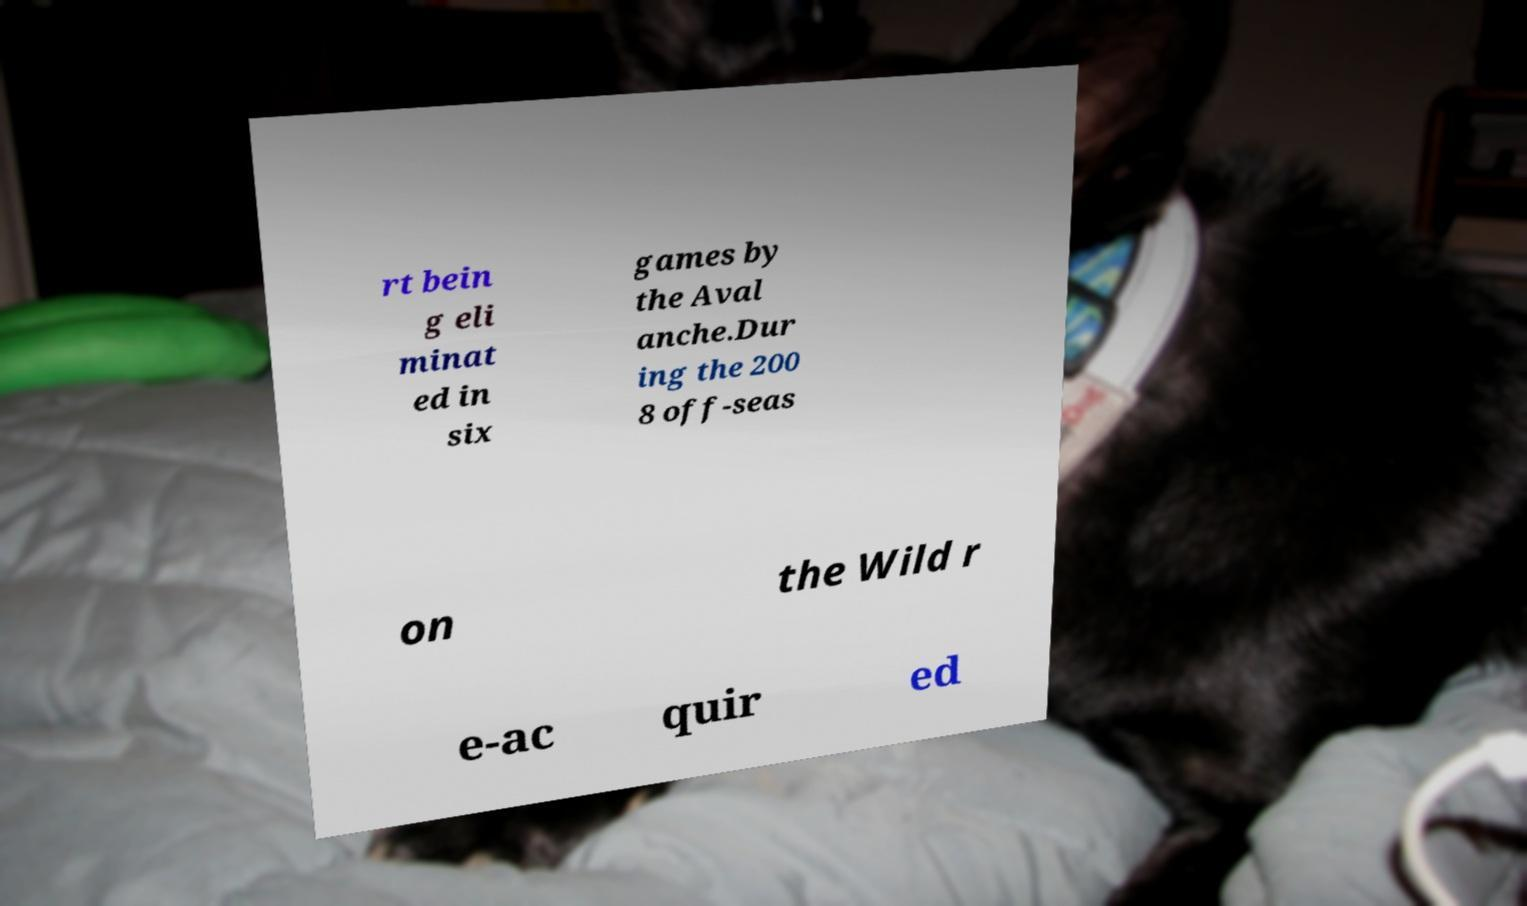I need the written content from this picture converted into text. Can you do that? rt bein g eli minat ed in six games by the Aval anche.Dur ing the 200 8 off-seas on the Wild r e-ac quir ed 